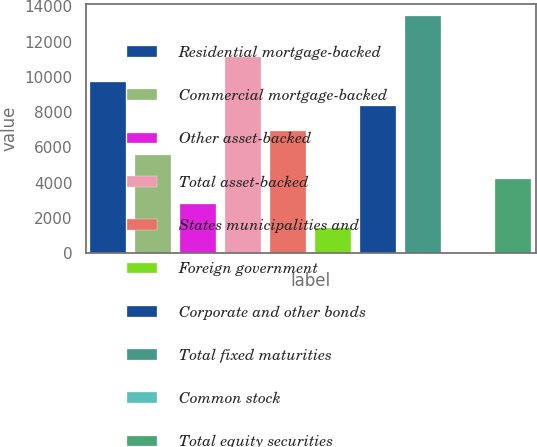Convert chart. <chart><loc_0><loc_0><loc_500><loc_500><bar_chart><fcel>Residential mortgage-backed<fcel>Commercial mortgage-backed<fcel>Other asset-backed<fcel>Total asset-backed<fcel>States municipalities and<fcel>Foreign government<fcel>Corporate and other bonds<fcel>Total fixed maturities<fcel>Common stock<fcel>Total equity securities<nl><fcel>9729<fcel>5568<fcel>2794<fcel>11116<fcel>6955<fcel>1407<fcel>8342<fcel>13444<fcel>20<fcel>4181<nl></chart> 